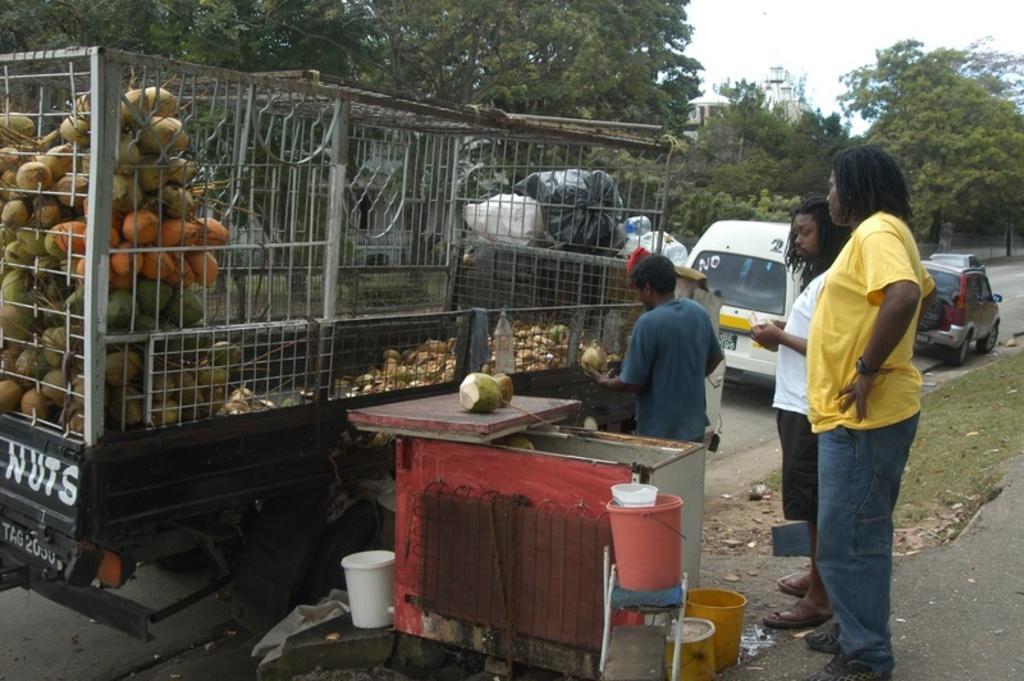How would you summarize this image in a sentence or two? In this picture we can see three people standing on the ground, vehicles on the road, coconuts, buckets, grass and some objects and in the background we can see trees and the sky. 